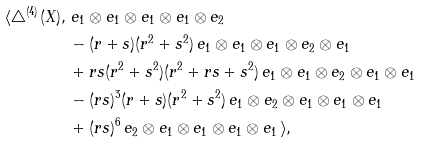<formula> <loc_0><loc_0><loc_500><loc_500>\langle \triangle ^ { ( 4 ) } ( X ) , \, & \, e _ { 1 } \otimes e _ { 1 } \otimes e _ { 1 } \otimes e _ { 1 } \otimes e _ { 2 } \\ & - ( r + s ) ( r ^ { 2 } + s ^ { 2 } ) \, e _ { 1 } \otimes e _ { 1 } \otimes e _ { 1 } \otimes e _ { 2 } \otimes e _ { 1 } \\ & + r s ( r ^ { 2 } + s ^ { 2 } ) ( r ^ { 2 } + r s + s ^ { 2 } ) \, e _ { 1 } \otimes e _ { 1 } \otimes e _ { 2 } \otimes e _ { 1 } \otimes e _ { 1 } \\ & - ( r s ) ^ { 3 } ( r + s ) ( r ^ { 2 } + s ^ { 2 } ) \, e _ { 1 } \otimes e _ { 2 } \otimes e _ { 1 } \otimes e _ { 1 } \otimes e _ { 1 } \\ & + ( r s ) ^ { 6 } \, e _ { 2 } \otimes e _ { 1 } \otimes e _ { 1 } \otimes e _ { 1 } \otimes e _ { 1 } \, \rangle ,</formula> 